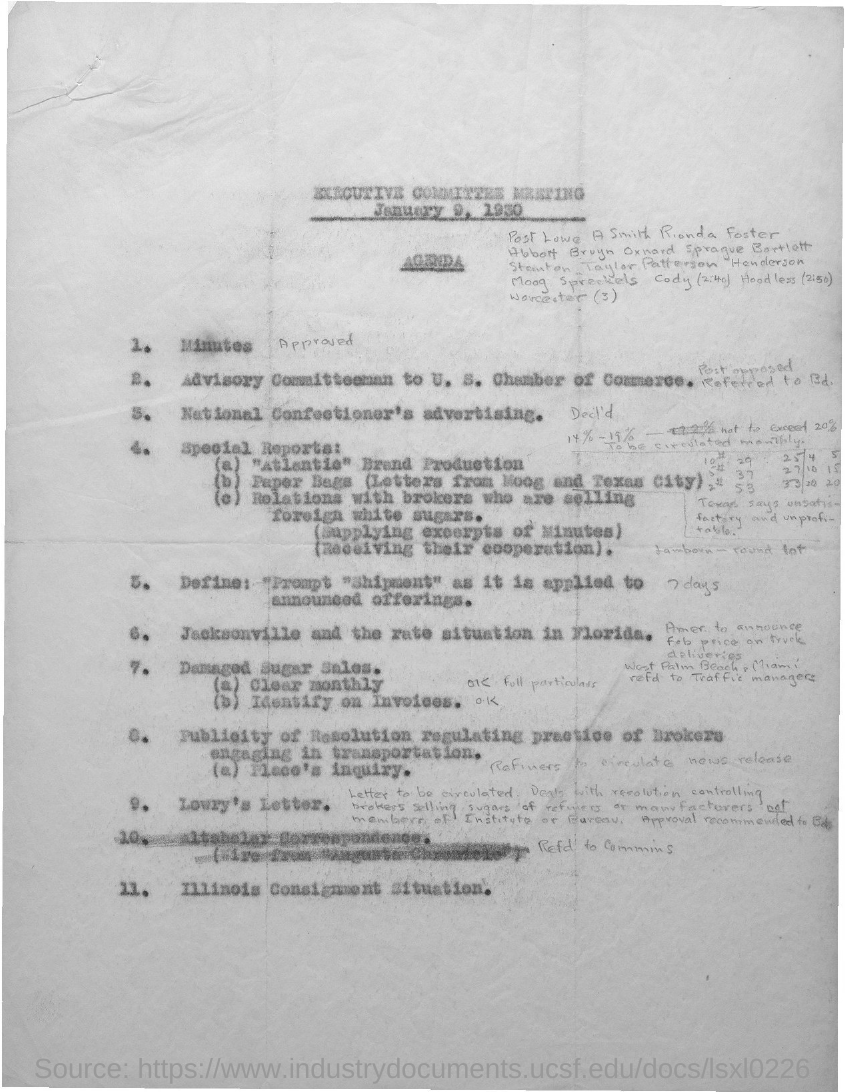When is the executive committee meeting held?
Offer a very short reply. January 9, 1930. 